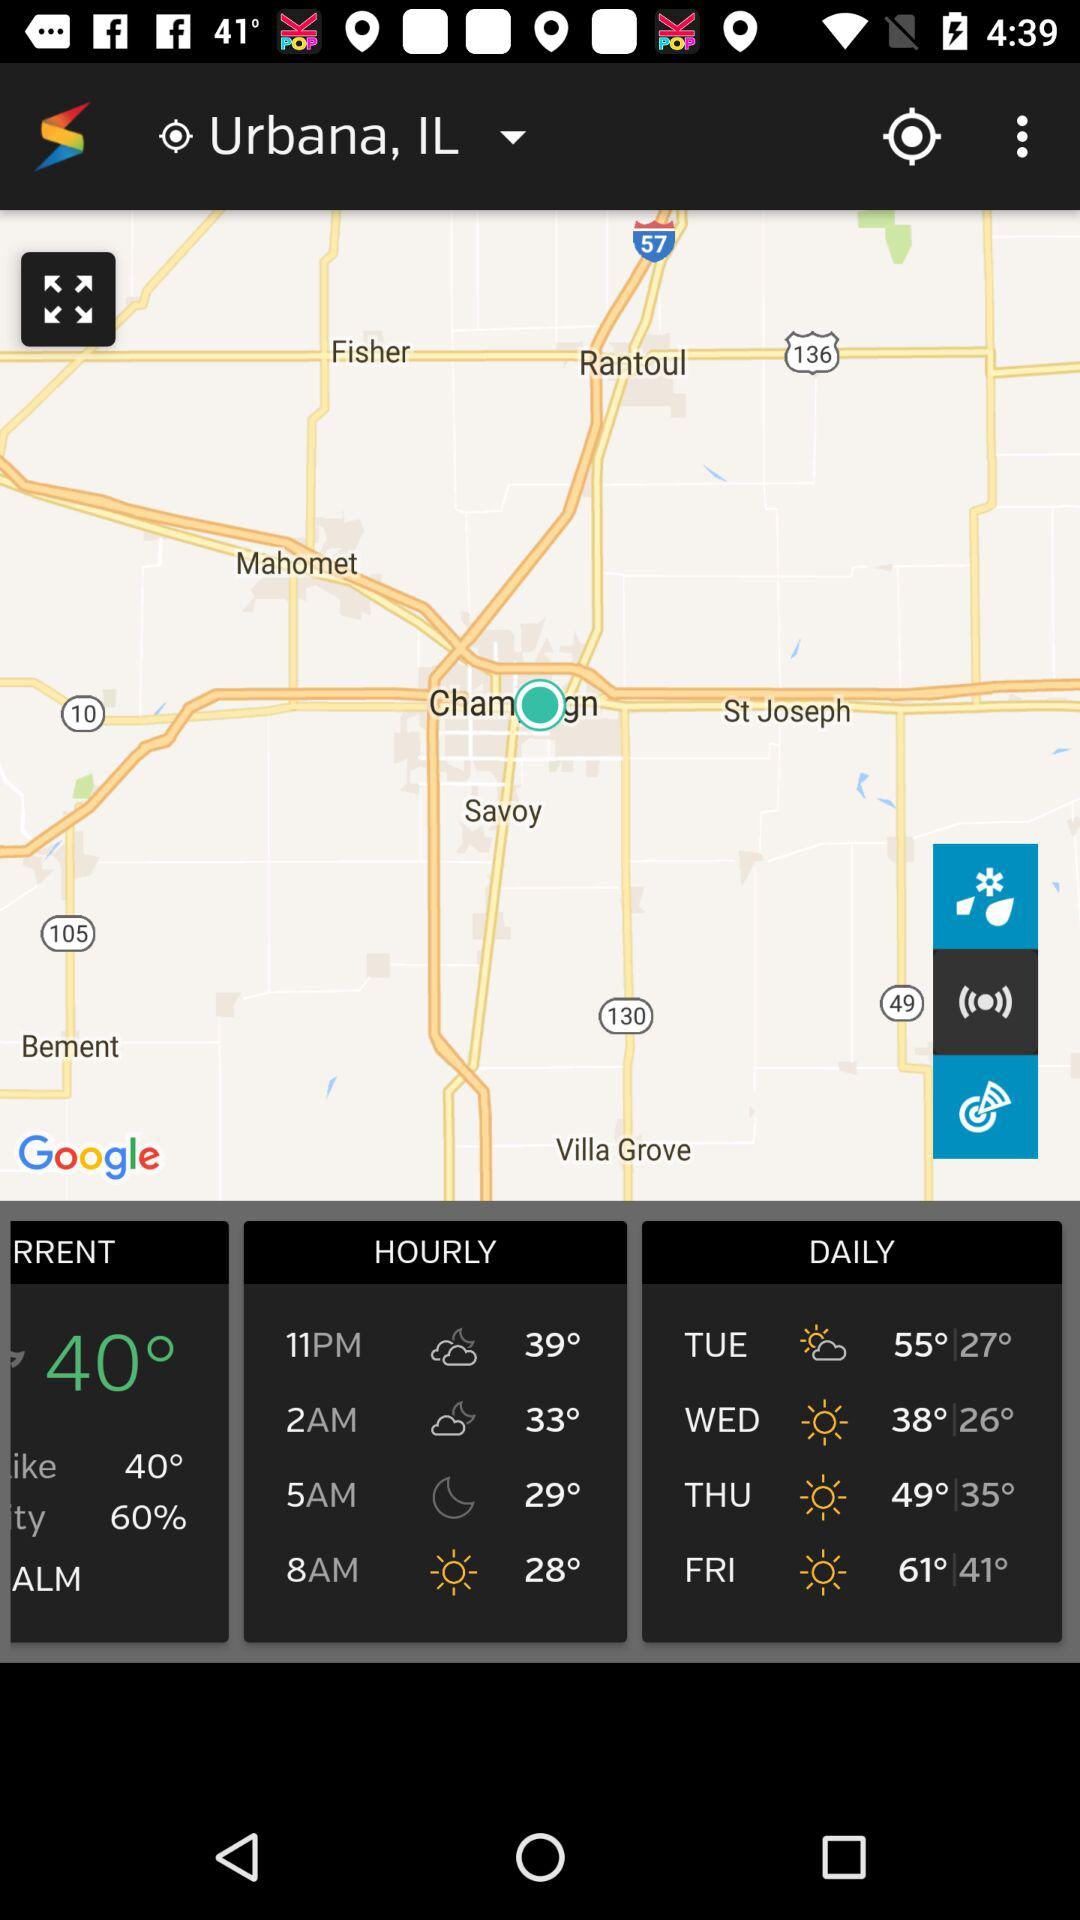What is the current location? The current location is Urbana, IL. 